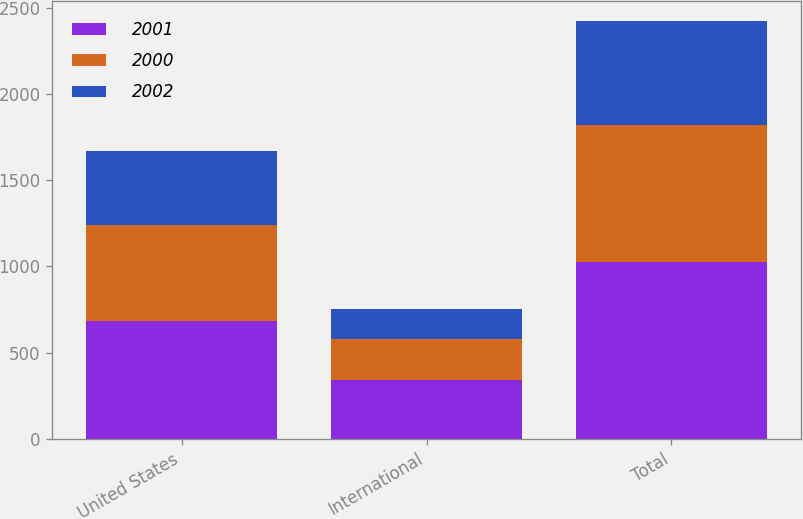Convert chart. <chart><loc_0><loc_0><loc_500><loc_500><stacked_bar_chart><ecel><fcel>United States<fcel>International<fcel>Total<nl><fcel>2001<fcel>680.3<fcel>343<fcel>1023.3<nl><fcel>2000<fcel>560.7<fcel>236<fcel>796.7<nl><fcel>2002<fcel>428.9<fcel>173.4<fcel>602.3<nl></chart> 